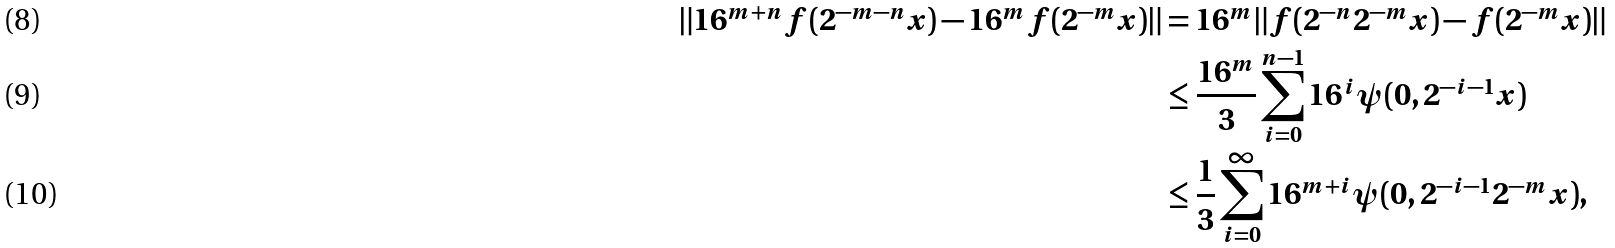Convert formula to latex. <formula><loc_0><loc_0><loc_500><loc_500>\| 1 6 ^ { m + n } { f ( 2 ^ { - m - n } x ) } - 1 6 ^ { m } { f ( 2 ^ { - m } x ) } \| & = { 1 6 ^ { m } } \| f ( 2 ^ { - n } 2 ^ { - m } x ) - f ( 2 ^ { - m } x ) \| \\ & \leq \frac { 1 6 ^ { m } } { 3 } \sum ^ { n - 1 } _ { i = 0 } 1 6 ^ { i } { \psi ( 0 , 2 ^ { - i - 1 } x ) } \\ & \leq \frac { 1 } { 3 } \sum ^ { \infty } _ { i = 0 } { 1 6 ^ { m + i } } { \psi ( 0 , 2 ^ { - i - 1 } 2 ^ { - m } x ) } ,</formula> 